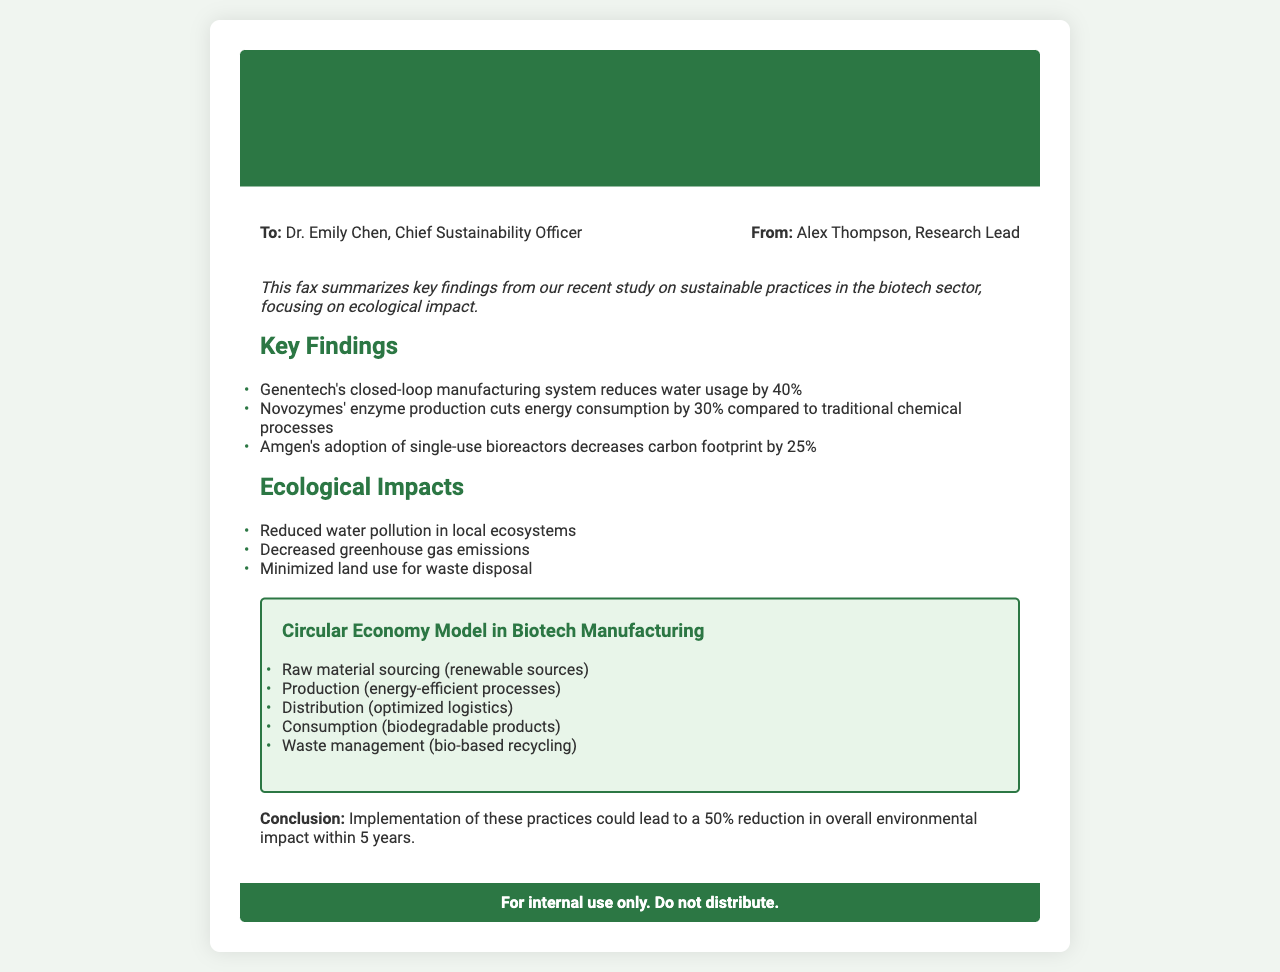What is the main topic of the fax? The main topic is indicated in the title of the fax, which discusses sustainable business practices in the biotechnology sector.
Answer: Sustainable Business Practices in Biotechnology Who is the sender of the fax? The sender's name is given in the document, specifically stating "From: Alex Thompson, Research Lead."
Answer: Alex Thompson What percentage does Genentech's system reduce water usage? The document states that Genentech's system reduces water usage by 40%.
Answer: 40% What ecological impact is noted concerning greenhouse gas emissions? The document mentions a decrease in greenhouse gas emissions as one of the ecological impacts.
Answer: Decreased greenhouse gas emissions What model does the diagram illustrate? The diagram heading indicates that it illustrates the "Circular Economy Model in Biotech Manufacturing."
Answer: Circular Economy Model in Biotech Manufacturing How much could the implementation of these practices reduce overall environmental impact in five years? The conclusion specifies that the implementation could lead to a 50% reduction in overall environmental impact within five years.
Answer: 50% What company is associated with single-use bioreactors? The document identifies Amgen as the company that adopts single-use bioreactors.
Answer: Amgen What process reduces energy consumption by 30%? The document states that Novozymes' enzyme production cuts energy consumption by 30%.
Answer: Enzyme production 